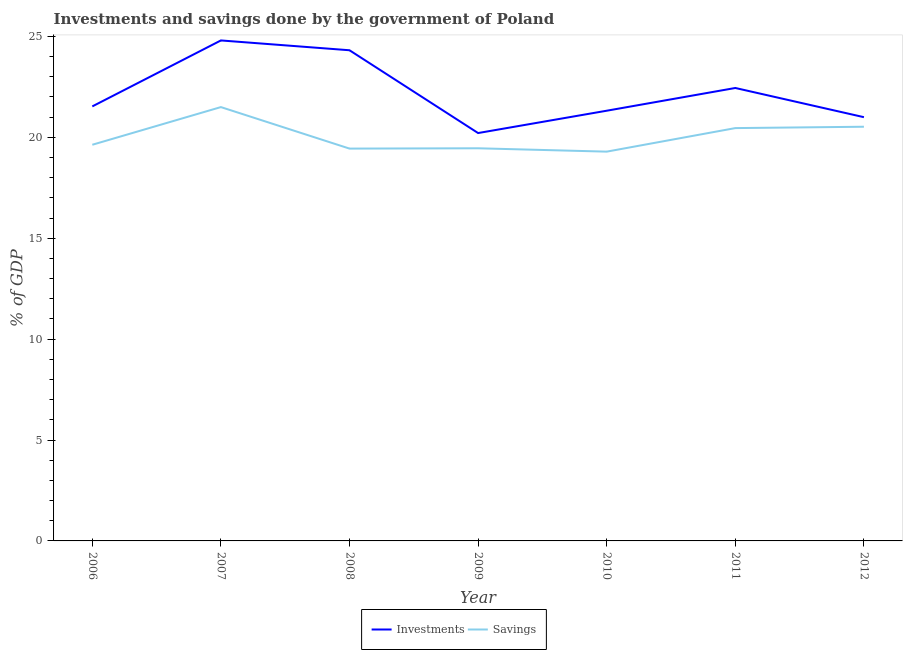How many different coloured lines are there?
Your response must be concise. 2. Is the number of lines equal to the number of legend labels?
Offer a terse response. Yes. What is the investments of government in 2008?
Keep it short and to the point. 24.31. Across all years, what is the maximum investments of government?
Your answer should be compact. 24.8. Across all years, what is the minimum investments of government?
Your answer should be compact. 20.21. In which year was the investments of government minimum?
Make the answer very short. 2009. What is the total savings of government in the graph?
Provide a succinct answer. 140.29. What is the difference between the savings of government in 2009 and that in 2012?
Your response must be concise. -1.07. What is the difference between the savings of government in 2008 and the investments of government in 2010?
Provide a succinct answer. -1.88. What is the average savings of government per year?
Give a very brief answer. 20.04. In the year 2010, what is the difference between the investments of government and savings of government?
Offer a very short reply. 2.03. In how many years, is the savings of government greater than 19 %?
Keep it short and to the point. 7. What is the ratio of the investments of government in 2007 to that in 2009?
Your response must be concise. 1.23. Is the savings of government in 2006 less than that in 2012?
Make the answer very short. Yes. Is the difference between the savings of government in 2007 and 2011 greater than the difference between the investments of government in 2007 and 2011?
Give a very brief answer. No. What is the difference between the highest and the second highest investments of government?
Offer a terse response. 0.49. What is the difference between the highest and the lowest investments of government?
Offer a very short reply. 4.59. Does the savings of government monotonically increase over the years?
Offer a very short reply. No. Is the investments of government strictly less than the savings of government over the years?
Provide a short and direct response. No. How many years are there in the graph?
Provide a succinct answer. 7. Are the values on the major ticks of Y-axis written in scientific E-notation?
Ensure brevity in your answer.  No. Does the graph contain any zero values?
Offer a terse response. No. Does the graph contain grids?
Make the answer very short. No. Where does the legend appear in the graph?
Your response must be concise. Bottom center. How many legend labels are there?
Provide a succinct answer. 2. What is the title of the graph?
Your answer should be compact. Investments and savings done by the government of Poland. Does "Transport services" appear as one of the legend labels in the graph?
Provide a succinct answer. No. What is the label or title of the Y-axis?
Provide a short and direct response. % of GDP. What is the % of GDP of Investments in 2006?
Your answer should be very brief. 21.53. What is the % of GDP of Savings in 2006?
Keep it short and to the point. 19.63. What is the % of GDP in Investments in 2007?
Your response must be concise. 24.8. What is the % of GDP of Savings in 2007?
Ensure brevity in your answer.  21.5. What is the % of GDP in Investments in 2008?
Offer a terse response. 24.31. What is the % of GDP of Savings in 2008?
Ensure brevity in your answer.  19.44. What is the % of GDP in Investments in 2009?
Give a very brief answer. 20.21. What is the % of GDP of Savings in 2009?
Provide a succinct answer. 19.46. What is the % of GDP of Investments in 2010?
Your answer should be compact. 21.32. What is the % of GDP of Savings in 2010?
Ensure brevity in your answer.  19.29. What is the % of GDP in Investments in 2011?
Offer a very short reply. 22.44. What is the % of GDP in Savings in 2011?
Offer a terse response. 20.46. What is the % of GDP in Investments in 2012?
Your answer should be very brief. 21. What is the % of GDP of Savings in 2012?
Offer a terse response. 20.52. Across all years, what is the maximum % of GDP in Investments?
Provide a succinct answer. 24.8. Across all years, what is the maximum % of GDP of Savings?
Keep it short and to the point. 21.5. Across all years, what is the minimum % of GDP of Investments?
Give a very brief answer. 20.21. Across all years, what is the minimum % of GDP in Savings?
Offer a very short reply. 19.29. What is the total % of GDP of Investments in the graph?
Make the answer very short. 155.61. What is the total % of GDP in Savings in the graph?
Provide a short and direct response. 140.29. What is the difference between the % of GDP of Investments in 2006 and that in 2007?
Make the answer very short. -3.27. What is the difference between the % of GDP in Savings in 2006 and that in 2007?
Give a very brief answer. -1.87. What is the difference between the % of GDP of Investments in 2006 and that in 2008?
Ensure brevity in your answer.  -2.78. What is the difference between the % of GDP of Savings in 2006 and that in 2008?
Offer a very short reply. 0.19. What is the difference between the % of GDP in Investments in 2006 and that in 2009?
Keep it short and to the point. 1.32. What is the difference between the % of GDP in Savings in 2006 and that in 2009?
Make the answer very short. 0.17. What is the difference between the % of GDP of Investments in 2006 and that in 2010?
Your response must be concise. 0.21. What is the difference between the % of GDP of Savings in 2006 and that in 2010?
Your response must be concise. 0.34. What is the difference between the % of GDP in Investments in 2006 and that in 2011?
Offer a terse response. -0.91. What is the difference between the % of GDP in Savings in 2006 and that in 2011?
Keep it short and to the point. -0.83. What is the difference between the % of GDP of Investments in 2006 and that in 2012?
Your answer should be compact. 0.53. What is the difference between the % of GDP in Savings in 2006 and that in 2012?
Provide a short and direct response. -0.89. What is the difference between the % of GDP of Investments in 2007 and that in 2008?
Give a very brief answer. 0.49. What is the difference between the % of GDP in Savings in 2007 and that in 2008?
Ensure brevity in your answer.  2.06. What is the difference between the % of GDP in Investments in 2007 and that in 2009?
Offer a very short reply. 4.59. What is the difference between the % of GDP in Savings in 2007 and that in 2009?
Your answer should be very brief. 2.04. What is the difference between the % of GDP in Investments in 2007 and that in 2010?
Your answer should be very brief. 3.48. What is the difference between the % of GDP of Savings in 2007 and that in 2010?
Your answer should be very brief. 2.21. What is the difference between the % of GDP of Investments in 2007 and that in 2011?
Your answer should be compact. 2.36. What is the difference between the % of GDP of Savings in 2007 and that in 2011?
Make the answer very short. 1.04. What is the difference between the % of GDP in Investments in 2007 and that in 2012?
Your answer should be very brief. 3.8. What is the difference between the % of GDP of Savings in 2007 and that in 2012?
Your answer should be very brief. 0.97. What is the difference between the % of GDP of Investments in 2008 and that in 2009?
Make the answer very short. 4.1. What is the difference between the % of GDP in Savings in 2008 and that in 2009?
Your answer should be compact. -0.02. What is the difference between the % of GDP of Investments in 2008 and that in 2010?
Your response must be concise. 3. What is the difference between the % of GDP in Savings in 2008 and that in 2010?
Keep it short and to the point. 0.15. What is the difference between the % of GDP in Investments in 2008 and that in 2011?
Your answer should be compact. 1.87. What is the difference between the % of GDP of Savings in 2008 and that in 2011?
Provide a short and direct response. -1.02. What is the difference between the % of GDP of Investments in 2008 and that in 2012?
Provide a short and direct response. 3.32. What is the difference between the % of GDP of Savings in 2008 and that in 2012?
Offer a very short reply. -1.08. What is the difference between the % of GDP of Investments in 2009 and that in 2010?
Ensure brevity in your answer.  -1.11. What is the difference between the % of GDP in Savings in 2009 and that in 2010?
Your answer should be very brief. 0.17. What is the difference between the % of GDP of Investments in 2009 and that in 2011?
Your answer should be very brief. -2.23. What is the difference between the % of GDP in Savings in 2009 and that in 2011?
Give a very brief answer. -1. What is the difference between the % of GDP in Investments in 2009 and that in 2012?
Offer a very short reply. -0.79. What is the difference between the % of GDP of Savings in 2009 and that in 2012?
Your answer should be very brief. -1.07. What is the difference between the % of GDP in Investments in 2010 and that in 2011?
Provide a succinct answer. -1.13. What is the difference between the % of GDP of Savings in 2010 and that in 2011?
Your answer should be compact. -1.17. What is the difference between the % of GDP in Investments in 2010 and that in 2012?
Ensure brevity in your answer.  0.32. What is the difference between the % of GDP in Savings in 2010 and that in 2012?
Offer a very short reply. -1.23. What is the difference between the % of GDP in Investments in 2011 and that in 2012?
Offer a terse response. 1.45. What is the difference between the % of GDP of Savings in 2011 and that in 2012?
Give a very brief answer. -0.07. What is the difference between the % of GDP in Investments in 2006 and the % of GDP in Savings in 2007?
Offer a terse response. 0.03. What is the difference between the % of GDP of Investments in 2006 and the % of GDP of Savings in 2008?
Your answer should be very brief. 2.09. What is the difference between the % of GDP of Investments in 2006 and the % of GDP of Savings in 2009?
Provide a succinct answer. 2.07. What is the difference between the % of GDP in Investments in 2006 and the % of GDP in Savings in 2010?
Your response must be concise. 2.24. What is the difference between the % of GDP in Investments in 2006 and the % of GDP in Savings in 2011?
Your response must be concise. 1.07. What is the difference between the % of GDP of Investments in 2006 and the % of GDP of Savings in 2012?
Provide a succinct answer. 1.01. What is the difference between the % of GDP in Investments in 2007 and the % of GDP in Savings in 2008?
Provide a short and direct response. 5.36. What is the difference between the % of GDP of Investments in 2007 and the % of GDP of Savings in 2009?
Ensure brevity in your answer.  5.34. What is the difference between the % of GDP in Investments in 2007 and the % of GDP in Savings in 2010?
Provide a short and direct response. 5.51. What is the difference between the % of GDP in Investments in 2007 and the % of GDP in Savings in 2011?
Provide a short and direct response. 4.34. What is the difference between the % of GDP in Investments in 2007 and the % of GDP in Savings in 2012?
Give a very brief answer. 4.28. What is the difference between the % of GDP in Investments in 2008 and the % of GDP in Savings in 2009?
Your response must be concise. 4.86. What is the difference between the % of GDP of Investments in 2008 and the % of GDP of Savings in 2010?
Offer a terse response. 5.02. What is the difference between the % of GDP of Investments in 2008 and the % of GDP of Savings in 2011?
Your answer should be compact. 3.86. What is the difference between the % of GDP of Investments in 2008 and the % of GDP of Savings in 2012?
Give a very brief answer. 3.79. What is the difference between the % of GDP in Investments in 2009 and the % of GDP in Savings in 2010?
Offer a terse response. 0.92. What is the difference between the % of GDP in Investments in 2009 and the % of GDP in Savings in 2011?
Your answer should be very brief. -0.25. What is the difference between the % of GDP of Investments in 2009 and the % of GDP of Savings in 2012?
Provide a short and direct response. -0.31. What is the difference between the % of GDP of Investments in 2010 and the % of GDP of Savings in 2011?
Your response must be concise. 0.86. What is the difference between the % of GDP in Investments in 2010 and the % of GDP in Savings in 2012?
Your answer should be very brief. 0.79. What is the difference between the % of GDP in Investments in 2011 and the % of GDP in Savings in 2012?
Make the answer very short. 1.92. What is the average % of GDP of Investments per year?
Provide a succinct answer. 22.23. What is the average % of GDP in Savings per year?
Provide a short and direct response. 20.04. In the year 2006, what is the difference between the % of GDP of Investments and % of GDP of Savings?
Your answer should be very brief. 1.9. In the year 2007, what is the difference between the % of GDP in Investments and % of GDP in Savings?
Give a very brief answer. 3.3. In the year 2008, what is the difference between the % of GDP of Investments and % of GDP of Savings?
Ensure brevity in your answer.  4.87. In the year 2009, what is the difference between the % of GDP of Investments and % of GDP of Savings?
Your answer should be very brief. 0.75. In the year 2010, what is the difference between the % of GDP of Investments and % of GDP of Savings?
Offer a very short reply. 2.03. In the year 2011, what is the difference between the % of GDP of Investments and % of GDP of Savings?
Offer a very short reply. 1.99. In the year 2012, what is the difference between the % of GDP of Investments and % of GDP of Savings?
Provide a succinct answer. 0.47. What is the ratio of the % of GDP of Investments in 2006 to that in 2007?
Keep it short and to the point. 0.87. What is the ratio of the % of GDP in Savings in 2006 to that in 2007?
Ensure brevity in your answer.  0.91. What is the ratio of the % of GDP of Investments in 2006 to that in 2008?
Your answer should be very brief. 0.89. What is the ratio of the % of GDP of Savings in 2006 to that in 2008?
Provide a succinct answer. 1.01. What is the ratio of the % of GDP in Investments in 2006 to that in 2009?
Give a very brief answer. 1.07. What is the ratio of the % of GDP of Savings in 2006 to that in 2010?
Provide a succinct answer. 1.02. What is the ratio of the % of GDP of Investments in 2006 to that in 2011?
Provide a short and direct response. 0.96. What is the ratio of the % of GDP of Savings in 2006 to that in 2011?
Offer a very short reply. 0.96. What is the ratio of the % of GDP of Investments in 2006 to that in 2012?
Offer a terse response. 1.03. What is the ratio of the % of GDP in Savings in 2006 to that in 2012?
Provide a short and direct response. 0.96. What is the ratio of the % of GDP in Investments in 2007 to that in 2008?
Your answer should be compact. 1.02. What is the ratio of the % of GDP of Savings in 2007 to that in 2008?
Offer a terse response. 1.11. What is the ratio of the % of GDP in Investments in 2007 to that in 2009?
Provide a short and direct response. 1.23. What is the ratio of the % of GDP of Savings in 2007 to that in 2009?
Your answer should be compact. 1.1. What is the ratio of the % of GDP in Investments in 2007 to that in 2010?
Offer a terse response. 1.16. What is the ratio of the % of GDP in Savings in 2007 to that in 2010?
Keep it short and to the point. 1.11. What is the ratio of the % of GDP in Investments in 2007 to that in 2011?
Provide a short and direct response. 1.1. What is the ratio of the % of GDP in Savings in 2007 to that in 2011?
Offer a very short reply. 1.05. What is the ratio of the % of GDP of Investments in 2007 to that in 2012?
Offer a very short reply. 1.18. What is the ratio of the % of GDP in Savings in 2007 to that in 2012?
Offer a terse response. 1.05. What is the ratio of the % of GDP of Investments in 2008 to that in 2009?
Provide a succinct answer. 1.2. What is the ratio of the % of GDP in Savings in 2008 to that in 2009?
Give a very brief answer. 1. What is the ratio of the % of GDP in Investments in 2008 to that in 2010?
Provide a succinct answer. 1.14. What is the ratio of the % of GDP of Savings in 2008 to that in 2010?
Your answer should be very brief. 1.01. What is the ratio of the % of GDP of Savings in 2008 to that in 2011?
Make the answer very short. 0.95. What is the ratio of the % of GDP in Investments in 2008 to that in 2012?
Offer a very short reply. 1.16. What is the ratio of the % of GDP of Savings in 2008 to that in 2012?
Provide a succinct answer. 0.95. What is the ratio of the % of GDP of Investments in 2009 to that in 2010?
Your answer should be very brief. 0.95. What is the ratio of the % of GDP in Savings in 2009 to that in 2010?
Your answer should be very brief. 1.01. What is the ratio of the % of GDP in Investments in 2009 to that in 2011?
Your response must be concise. 0.9. What is the ratio of the % of GDP of Savings in 2009 to that in 2011?
Offer a very short reply. 0.95. What is the ratio of the % of GDP of Investments in 2009 to that in 2012?
Give a very brief answer. 0.96. What is the ratio of the % of GDP in Savings in 2009 to that in 2012?
Offer a terse response. 0.95. What is the ratio of the % of GDP in Investments in 2010 to that in 2011?
Offer a terse response. 0.95. What is the ratio of the % of GDP of Savings in 2010 to that in 2011?
Your answer should be very brief. 0.94. What is the ratio of the % of GDP in Investments in 2010 to that in 2012?
Your response must be concise. 1.02. What is the ratio of the % of GDP in Savings in 2010 to that in 2012?
Keep it short and to the point. 0.94. What is the ratio of the % of GDP of Investments in 2011 to that in 2012?
Provide a short and direct response. 1.07. What is the ratio of the % of GDP of Savings in 2011 to that in 2012?
Provide a short and direct response. 1. What is the difference between the highest and the second highest % of GDP of Investments?
Provide a short and direct response. 0.49. What is the difference between the highest and the second highest % of GDP of Savings?
Offer a terse response. 0.97. What is the difference between the highest and the lowest % of GDP of Investments?
Give a very brief answer. 4.59. What is the difference between the highest and the lowest % of GDP of Savings?
Your response must be concise. 2.21. 